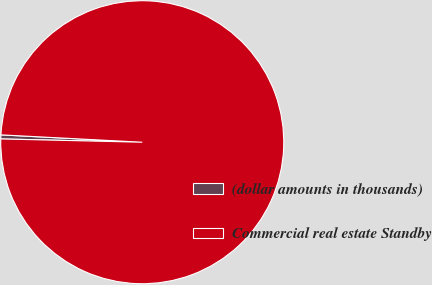Convert chart to OTSL. <chart><loc_0><loc_0><loc_500><loc_500><pie_chart><fcel>(dollar amounts in thousands)<fcel>Commercial real estate Standby<nl><fcel>0.46%<fcel>99.54%<nl></chart> 